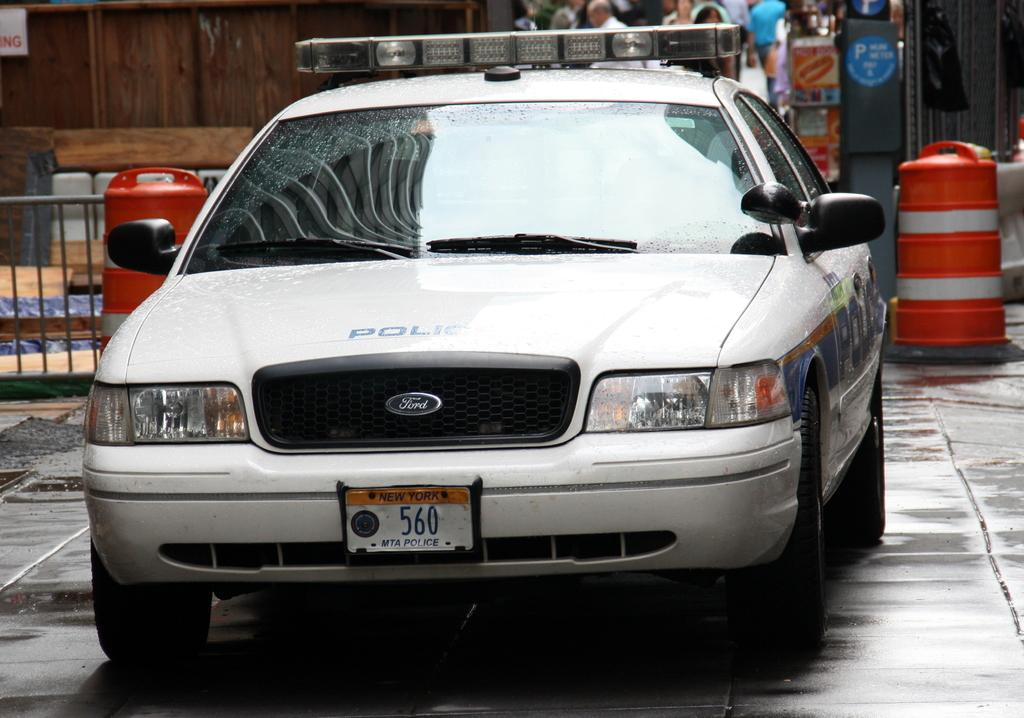What type of vehicle is present in the image? There is a car in the image. What type of barrier can be seen in the image? There is a metal fence in the image. What type of wall is visible in the image? There is a wooden wall in the image. What other wooden objects can be seen in the image? There are other wooden objects in the image. What type of tomatoes can be seen growing on the wooden wall in the image? There are no tomatoes present in the image, and they are not growing on the wooden wall. 